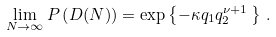<formula> <loc_0><loc_0><loc_500><loc_500>\lim _ { N \to \infty } P \left ( D ( N ) \right ) = \exp \left \{ - \kappa q _ { 1 } q _ { 2 } ^ { \nu + 1 } \, \right \} \, .</formula> 